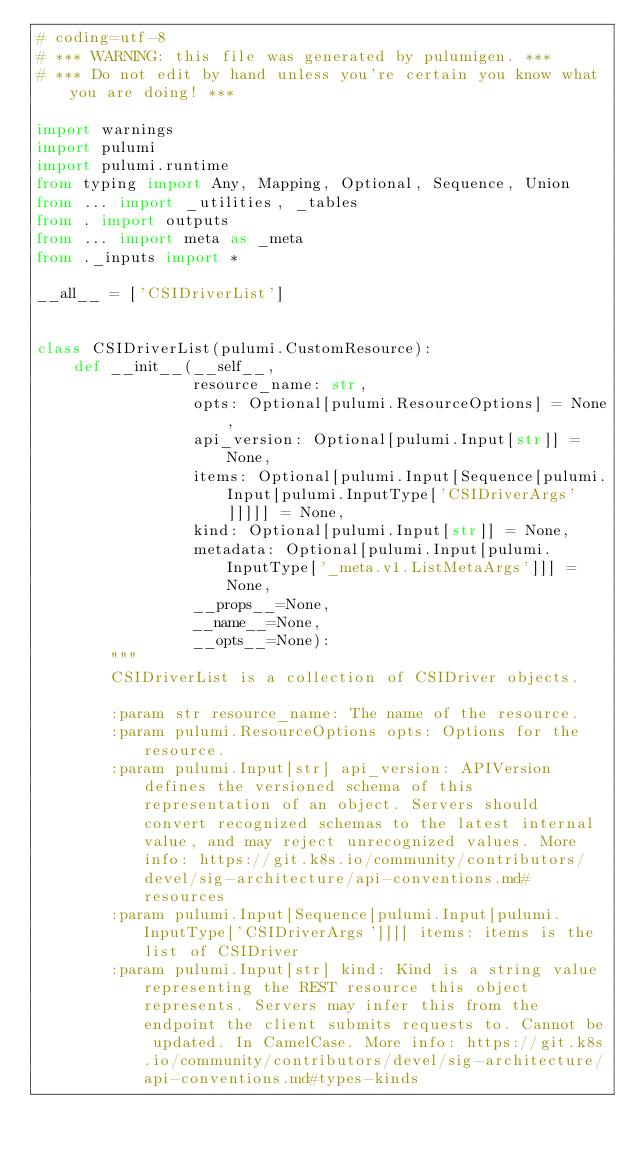<code> <loc_0><loc_0><loc_500><loc_500><_Python_># coding=utf-8
# *** WARNING: this file was generated by pulumigen. ***
# *** Do not edit by hand unless you're certain you know what you are doing! ***

import warnings
import pulumi
import pulumi.runtime
from typing import Any, Mapping, Optional, Sequence, Union
from ... import _utilities, _tables
from . import outputs
from ... import meta as _meta
from ._inputs import *

__all__ = ['CSIDriverList']


class CSIDriverList(pulumi.CustomResource):
    def __init__(__self__,
                 resource_name: str,
                 opts: Optional[pulumi.ResourceOptions] = None,
                 api_version: Optional[pulumi.Input[str]] = None,
                 items: Optional[pulumi.Input[Sequence[pulumi.Input[pulumi.InputType['CSIDriverArgs']]]]] = None,
                 kind: Optional[pulumi.Input[str]] = None,
                 metadata: Optional[pulumi.Input[pulumi.InputType['_meta.v1.ListMetaArgs']]] = None,
                 __props__=None,
                 __name__=None,
                 __opts__=None):
        """
        CSIDriverList is a collection of CSIDriver objects.

        :param str resource_name: The name of the resource.
        :param pulumi.ResourceOptions opts: Options for the resource.
        :param pulumi.Input[str] api_version: APIVersion defines the versioned schema of this representation of an object. Servers should convert recognized schemas to the latest internal value, and may reject unrecognized values. More info: https://git.k8s.io/community/contributors/devel/sig-architecture/api-conventions.md#resources
        :param pulumi.Input[Sequence[pulumi.Input[pulumi.InputType['CSIDriverArgs']]]] items: items is the list of CSIDriver
        :param pulumi.Input[str] kind: Kind is a string value representing the REST resource this object represents. Servers may infer this from the endpoint the client submits requests to. Cannot be updated. In CamelCase. More info: https://git.k8s.io/community/contributors/devel/sig-architecture/api-conventions.md#types-kinds</code> 